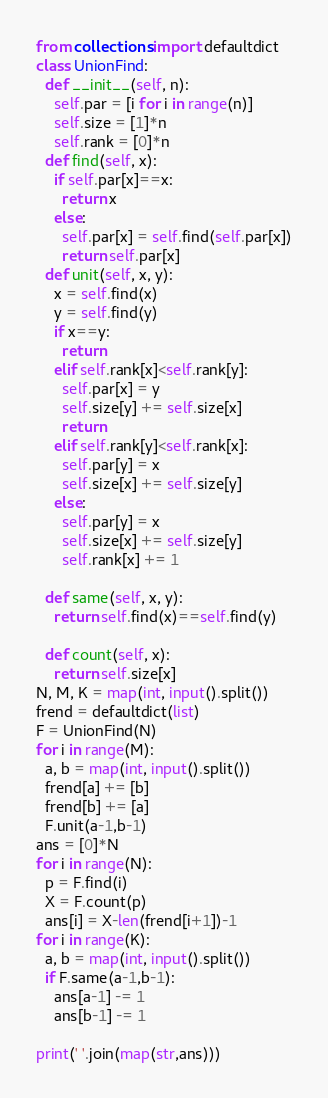<code> <loc_0><loc_0><loc_500><loc_500><_Python_>from collections import defaultdict
class UnionFind:
  def __init__(self, n):
    self.par = [i for i in range(n)]
    self.size = [1]*n
    self.rank = [0]*n
  def find(self, x):
    if self.par[x]==x:
      return x
    else:
      self.par[x] = self.find(self.par[x])
      return self.par[x]
  def unit(self, x, y):
    x = self.find(x)
    y = self.find(y)
    if x==y:
      return
    elif self.rank[x]<self.rank[y]:
      self.par[x] = y
      self.size[y] += self.size[x]
      return
    elif self.rank[y]<self.rank[x]:
      self.par[y] = x
      self.size[x] += self.size[y]
    else:
      self.par[y] = x
      self.size[x] += self.size[y]
      self.rank[x] += 1
      
  def same(self, x, y):
    return self.find(x)==self.find(y)
  
  def count(self, x):
    return self.size[x]
N, M, K = map(int, input().split())
frend = defaultdict(list)
F = UnionFind(N)
for i in range(M):
  a, b = map(int, input().split())
  frend[a] += [b]
  frend[b] += [a]
  F.unit(a-1,b-1)
ans = [0]*N
for i in range(N):
  p = F.find(i)
  X = F.count(p)
  ans[i] = X-len(frend[i+1])-1
for i in range(K):
  a, b = map(int, input().split())
  if F.same(a-1,b-1):
    ans[a-1] -= 1
    ans[b-1] -= 1

print(' '.join(map(str,ans)))</code> 